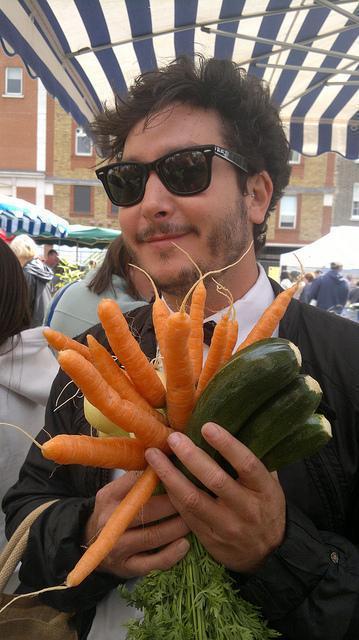What kind of green vegetable is held underneath of the carrots like a card?
Make your selection and explain in format: 'Answer: answer
Rationale: rationale.'
Options: Hops, cucumber, broccoli, spinach. Answer: cucumber.
Rationale: There is a cucumber or zuchinni with the carrots. 